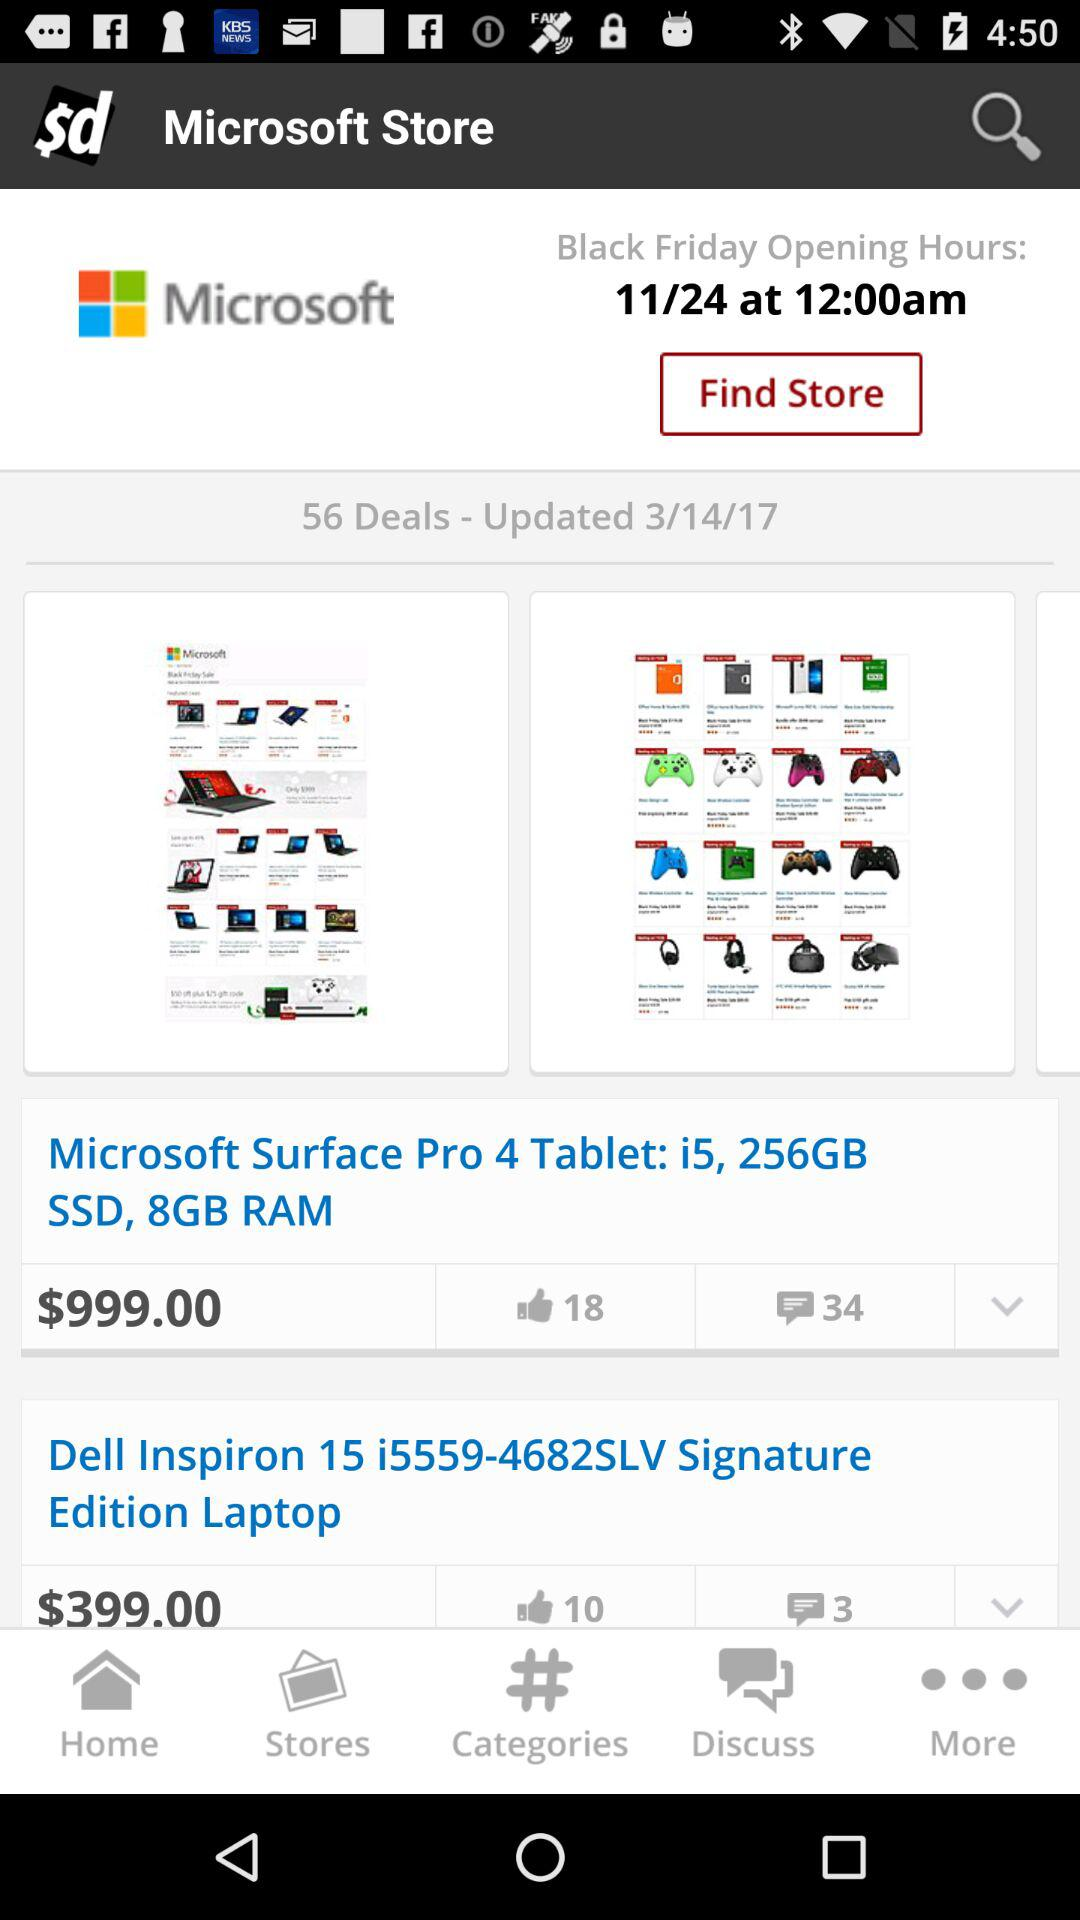How much does the "Dell Inspiron 15 i5559-4682SLV Signature Edition Laptop" cost? The "Dell Inspiron 15 i5559-4682SLV Signature Edition Laptop" costs $399.00. 